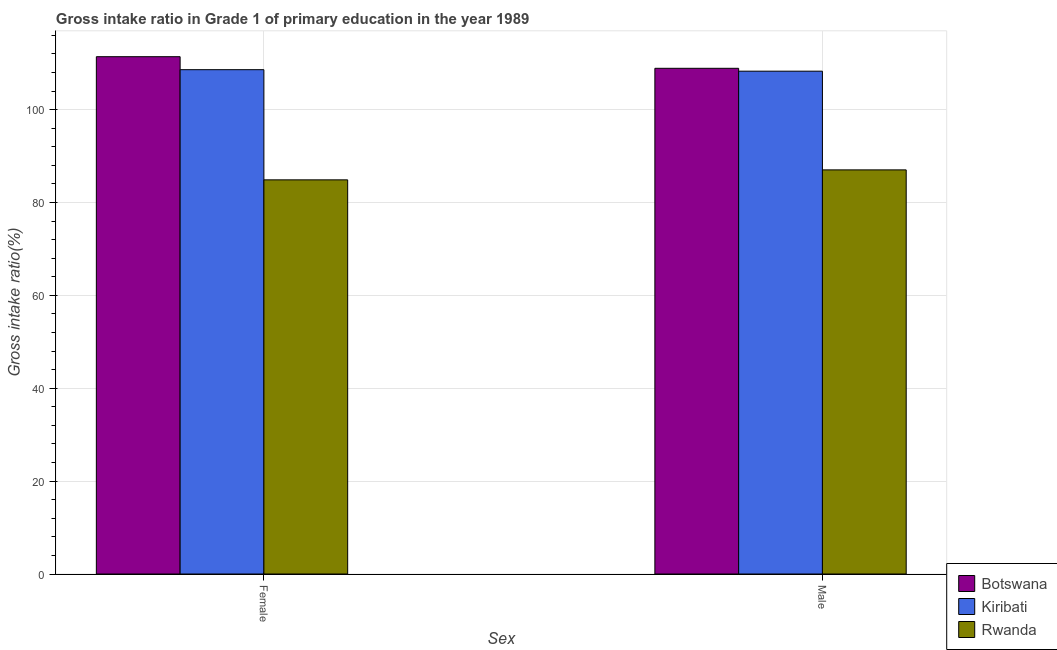How many different coloured bars are there?
Offer a terse response. 3. Are the number of bars per tick equal to the number of legend labels?
Ensure brevity in your answer.  Yes. How many bars are there on the 2nd tick from the left?
Give a very brief answer. 3. How many bars are there on the 1st tick from the right?
Provide a short and direct response. 3. What is the gross intake ratio(female) in Kiribati?
Offer a very short reply. 108.61. Across all countries, what is the maximum gross intake ratio(male)?
Your answer should be very brief. 108.91. Across all countries, what is the minimum gross intake ratio(male)?
Keep it short and to the point. 87.03. In which country was the gross intake ratio(female) maximum?
Offer a terse response. Botswana. In which country was the gross intake ratio(female) minimum?
Ensure brevity in your answer.  Rwanda. What is the total gross intake ratio(male) in the graph?
Keep it short and to the point. 304.24. What is the difference between the gross intake ratio(male) in Botswana and that in Rwanda?
Give a very brief answer. 21.88. What is the difference between the gross intake ratio(female) in Kiribati and the gross intake ratio(male) in Rwanda?
Offer a very short reply. 21.58. What is the average gross intake ratio(female) per country?
Provide a short and direct response. 101.64. What is the difference between the gross intake ratio(female) and gross intake ratio(male) in Kiribati?
Provide a short and direct response. 0.32. What is the ratio of the gross intake ratio(male) in Botswana to that in Kiribati?
Provide a short and direct response. 1.01. In how many countries, is the gross intake ratio(female) greater than the average gross intake ratio(female) taken over all countries?
Offer a terse response. 2. What does the 3rd bar from the left in Male represents?
Your response must be concise. Rwanda. What does the 3rd bar from the right in Male represents?
Offer a very short reply. Botswana. Are the values on the major ticks of Y-axis written in scientific E-notation?
Your answer should be very brief. No. Does the graph contain grids?
Your response must be concise. Yes. How many legend labels are there?
Offer a terse response. 3. What is the title of the graph?
Provide a short and direct response. Gross intake ratio in Grade 1 of primary education in the year 1989. What is the label or title of the X-axis?
Provide a succinct answer. Sex. What is the label or title of the Y-axis?
Provide a succinct answer. Gross intake ratio(%). What is the Gross intake ratio(%) in Botswana in Female?
Ensure brevity in your answer.  111.41. What is the Gross intake ratio(%) in Kiribati in Female?
Your answer should be compact. 108.61. What is the Gross intake ratio(%) in Rwanda in Female?
Give a very brief answer. 84.89. What is the Gross intake ratio(%) in Botswana in Male?
Provide a short and direct response. 108.91. What is the Gross intake ratio(%) in Kiribati in Male?
Ensure brevity in your answer.  108.29. What is the Gross intake ratio(%) of Rwanda in Male?
Ensure brevity in your answer.  87.03. Across all Sex, what is the maximum Gross intake ratio(%) in Botswana?
Make the answer very short. 111.41. Across all Sex, what is the maximum Gross intake ratio(%) of Kiribati?
Ensure brevity in your answer.  108.61. Across all Sex, what is the maximum Gross intake ratio(%) of Rwanda?
Offer a terse response. 87.03. Across all Sex, what is the minimum Gross intake ratio(%) of Botswana?
Your answer should be compact. 108.91. Across all Sex, what is the minimum Gross intake ratio(%) in Kiribati?
Your answer should be compact. 108.29. Across all Sex, what is the minimum Gross intake ratio(%) in Rwanda?
Ensure brevity in your answer.  84.89. What is the total Gross intake ratio(%) in Botswana in the graph?
Give a very brief answer. 220.32. What is the total Gross intake ratio(%) of Kiribati in the graph?
Your answer should be very brief. 216.9. What is the total Gross intake ratio(%) in Rwanda in the graph?
Provide a short and direct response. 171.92. What is the difference between the Gross intake ratio(%) in Botswana in Female and that in Male?
Provide a succinct answer. 2.5. What is the difference between the Gross intake ratio(%) in Kiribati in Female and that in Male?
Provide a short and direct response. 0.32. What is the difference between the Gross intake ratio(%) in Rwanda in Female and that in Male?
Your response must be concise. -2.15. What is the difference between the Gross intake ratio(%) in Botswana in Female and the Gross intake ratio(%) in Kiribati in Male?
Offer a very short reply. 3.12. What is the difference between the Gross intake ratio(%) in Botswana in Female and the Gross intake ratio(%) in Rwanda in Male?
Make the answer very short. 24.38. What is the difference between the Gross intake ratio(%) in Kiribati in Female and the Gross intake ratio(%) in Rwanda in Male?
Provide a short and direct response. 21.58. What is the average Gross intake ratio(%) in Botswana per Sex?
Your answer should be compact. 110.16. What is the average Gross intake ratio(%) of Kiribati per Sex?
Offer a terse response. 108.45. What is the average Gross intake ratio(%) of Rwanda per Sex?
Provide a succinct answer. 85.96. What is the difference between the Gross intake ratio(%) in Botswana and Gross intake ratio(%) in Kiribati in Female?
Your answer should be very brief. 2.8. What is the difference between the Gross intake ratio(%) of Botswana and Gross intake ratio(%) of Rwanda in Female?
Your response must be concise. 26.52. What is the difference between the Gross intake ratio(%) in Kiribati and Gross intake ratio(%) in Rwanda in Female?
Provide a short and direct response. 23.73. What is the difference between the Gross intake ratio(%) in Botswana and Gross intake ratio(%) in Kiribati in Male?
Provide a succinct answer. 0.62. What is the difference between the Gross intake ratio(%) of Botswana and Gross intake ratio(%) of Rwanda in Male?
Your answer should be very brief. 21.88. What is the difference between the Gross intake ratio(%) of Kiribati and Gross intake ratio(%) of Rwanda in Male?
Your answer should be compact. 21.26. What is the ratio of the Gross intake ratio(%) in Botswana in Female to that in Male?
Provide a short and direct response. 1.02. What is the ratio of the Gross intake ratio(%) in Kiribati in Female to that in Male?
Offer a terse response. 1. What is the ratio of the Gross intake ratio(%) in Rwanda in Female to that in Male?
Keep it short and to the point. 0.98. What is the difference between the highest and the second highest Gross intake ratio(%) in Botswana?
Your response must be concise. 2.5. What is the difference between the highest and the second highest Gross intake ratio(%) of Kiribati?
Keep it short and to the point. 0.32. What is the difference between the highest and the second highest Gross intake ratio(%) in Rwanda?
Make the answer very short. 2.15. What is the difference between the highest and the lowest Gross intake ratio(%) of Botswana?
Ensure brevity in your answer.  2.5. What is the difference between the highest and the lowest Gross intake ratio(%) of Kiribati?
Your answer should be compact. 0.32. What is the difference between the highest and the lowest Gross intake ratio(%) of Rwanda?
Ensure brevity in your answer.  2.15. 